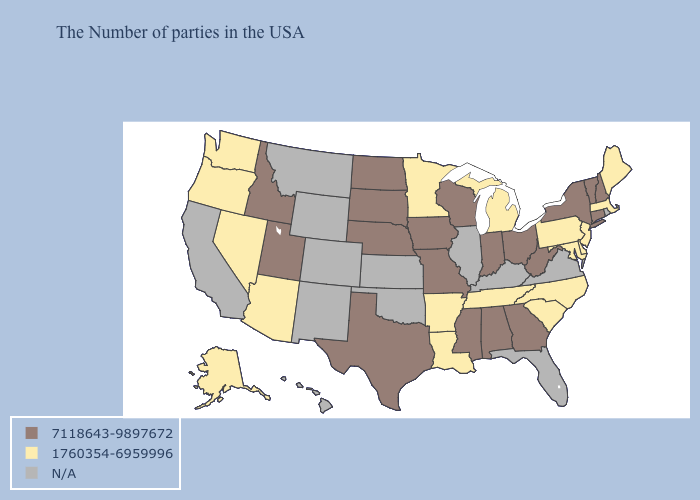Name the states that have a value in the range 7118643-9897672?
Answer briefly. New Hampshire, Vermont, Connecticut, New York, West Virginia, Ohio, Georgia, Indiana, Alabama, Wisconsin, Mississippi, Missouri, Iowa, Nebraska, Texas, South Dakota, North Dakota, Utah, Idaho. What is the value of Wyoming?
Concise answer only. N/A. Does Alaska have the lowest value in the West?
Answer briefly. Yes. Is the legend a continuous bar?
Write a very short answer. No. What is the lowest value in the USA?
Keep it brief. 1760354-6959996. What is the highest value in the USA?
Give a very brief answer. 7118643-9897672. Name the states that have a value in the range 1760354-6959996?
Concise answer only. Maine, Massachusetts, New Jersey, Delaware, Maryland, Pennsylvania, North Carolina, South Carolina, Michigan, Tennessee, Louisiana, Arkansas, Minnesota, Arizona, Nevada, Washington, Oregon, Alaska. What is the value of Mississippi?
Concise answer only. 7118643-9897672. Name the states that have a value in the range N/A?
Give a very brief answer. Rhode Island, Virginia, Florida, Kentucky, Illinois, Kansas, Oklahoma, Wyoming, Colorado, New Mexico, Montana, California, Hawaii. What is the value of Idaho?
Keep it brief. 7118643-9897672. What is the value of New Hampshire?
Give a very brief answer. 7118643-9897672. Among the states that border North Carolina , which have the lowest value?
Concise answer only. South Carolina, Tennessee. What is the highest value in states that border Florida?
Quick response, please. 7118643-9897672. Name the states that have a value in the range 7118643-9897672?
Keep it brief. New Hampshire, Vermont, Connecticut, New York, West Virginia, Ohio, Georgia, Indiana, Alabama, Wisconsin, Mississippi, Missouri, Iowa, Nebraska, Texas, South Dakota, North Dakota, Utah, Idaho. Among the states that border Pennsylvania , which have the lowest value?
Write a very short answer. New Jersey, Delaware, Maryland. 